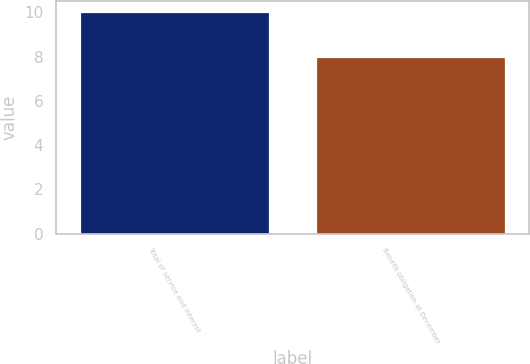Convert chart to OTSL. <chart><loc_0><loc_0><loc_500><loc_500><bar_chart><fcel>Total of service and interest<fcel>Benefit obligation at December<nl><fcel>10<fcel>8<nl></chart> 